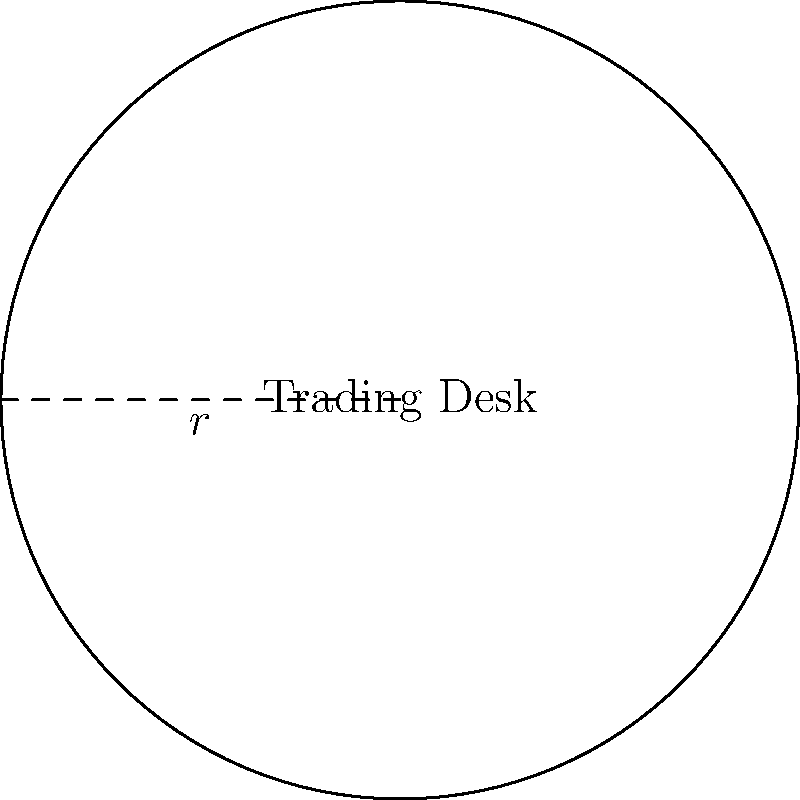A circular trading desk arrangement has a radius of 5 meters. What is the perimeter of the desk setup, rounded to the nearest centimeter? To find the perimeter of a circular arrangement, we need to calculate the circumference of the circle. The formula for the circumference of a circle is:

$$C = 2\pi r$$

Where:
$C$ is the circumference (perimeter)
$\pi$ is approximately 3.14159
$r$ is the radius

Given:
$r = 5$ meters

Step 1: Substitute the values into the formula
$$C = 2\pi (5)$$

Step 2: Multiply
$$C = 10\pi$$

Step 3: Calculate the result
$$C \approx 10 * 3.14159 = 31.4159\text{ meters}$$

Step 4: Convert to centimeters
$$31.4159\text{ meters} * 100 = 3141.59\text{ centimeters}$$

Step 5: Round to the nearest centimeter
$$3141.59\text{ cm} \approx 3141.6\text{ cm}$$

Therefore, the perimeter of the circular trading desk arrangement is approximately 3141.6 cm.
Answer: 3141.6 cm 